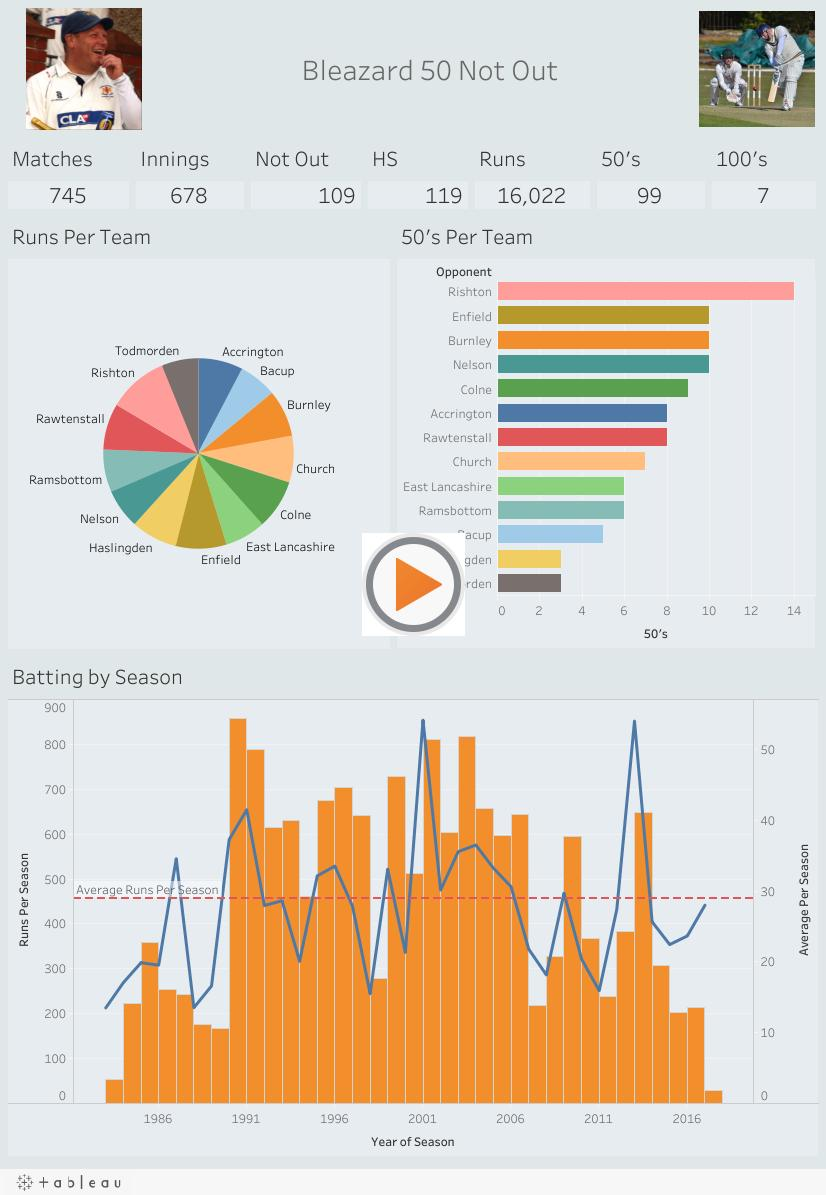Highlight a few significant elements in this photo. Seven 50s were scored against the Church team during the match. The number of 50s scored by Bleazard was 99. He played 678 innings. Bleazard scored a total of 7 hundreds. In the match against Colne, a total of 9 50's were scored. 